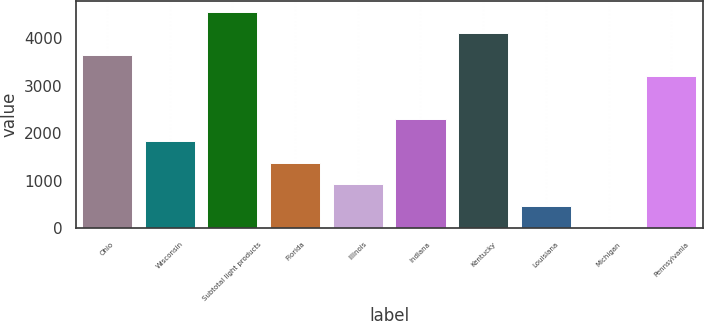Convert chart. <chart><loc_0><loc_0><loc_500><loc_500><bar_chart><fcel>Ohio<fcel>Wisconsin<fcel>Subtotal light products<fcel>Florida<fcel>Illinois<fcel>Indiana<fcel>Kentucky<fcel>Louisiana<fcel>Michigan<fcel>Pennsylvania<nl><fcel>3656<fcel>1834<fcel>4567<fcel>1378.5<fcel>923<fcel>2289.5<fcel>4111.5<fcel>467.5<fcel>12<fcel>3200.5<nl></chart> 